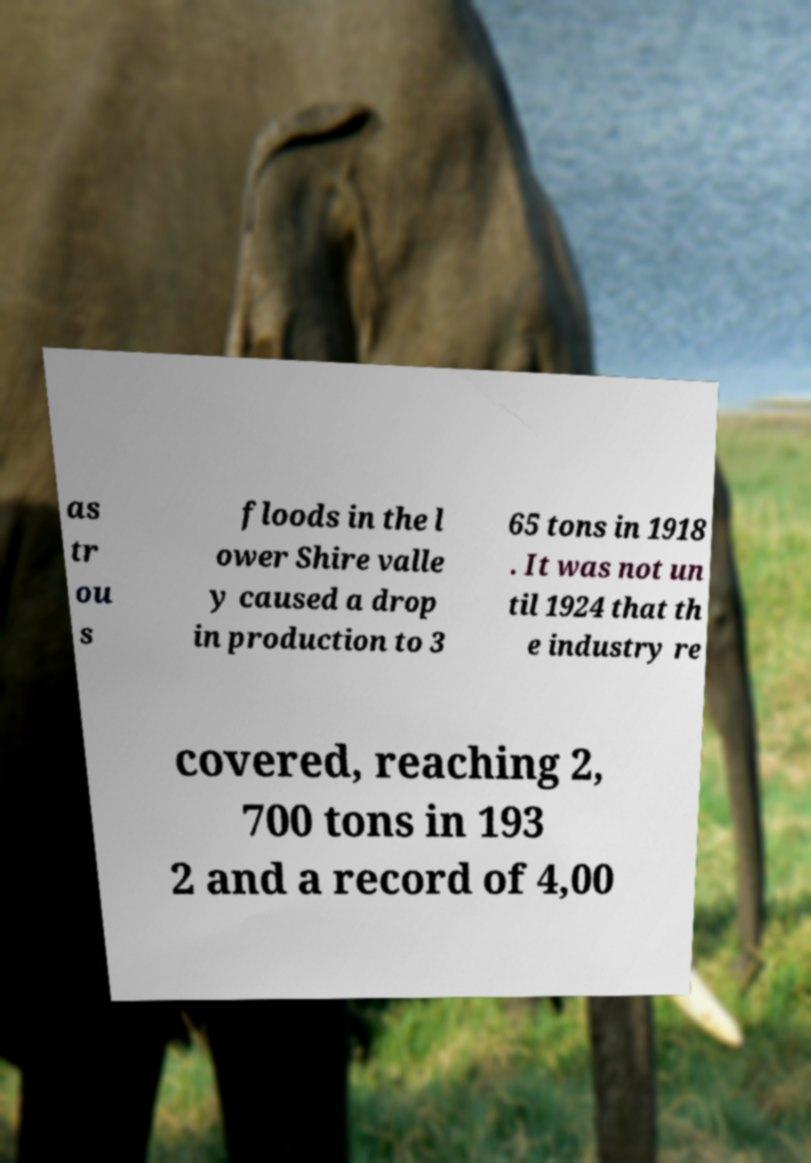There's text embedded in this image that I need extracted. Can you transcribe it verbatim? as tr ou s floods in the l ower Shire valle y caused a drop in production to 3 65 tons in 1918 . It was not un til 1924 that th e industry re covered, reaching 2, 700 tons in 193 2 and a record of 4,00 